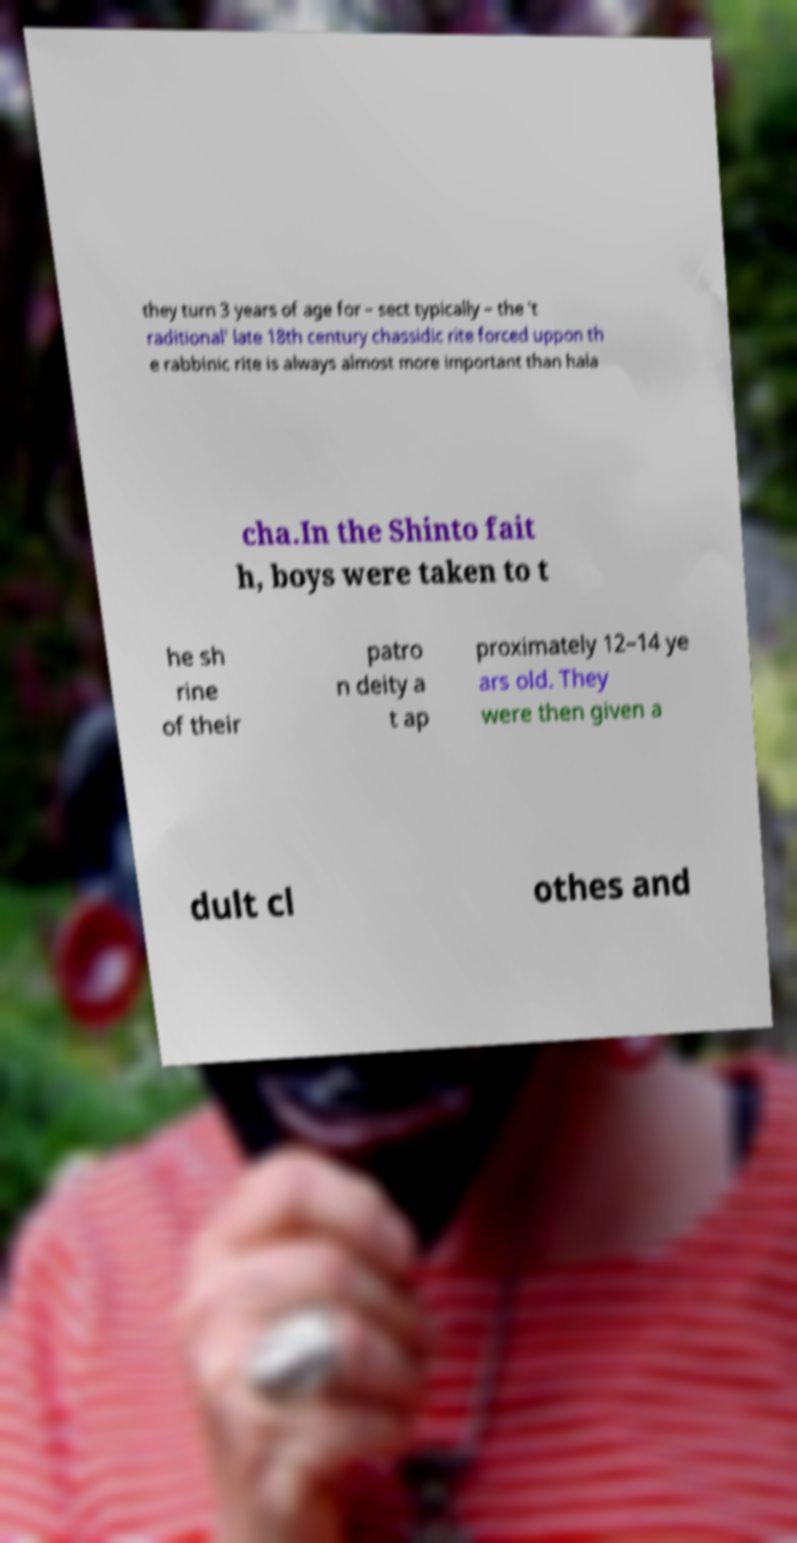Can you accurately transcribe the text from the provided image for me? they turn 3 years of age for – sect typically – the ′t raditional′ late 18th century chassidic rite forced uppon th e rabbinic rite is always almost more important than hala cha.In the Shinto fait h, boys were taken to t he sh rine of their patro n deity a t ap proximately 12–14 ye ars old. They were then given a dult cl othes and 